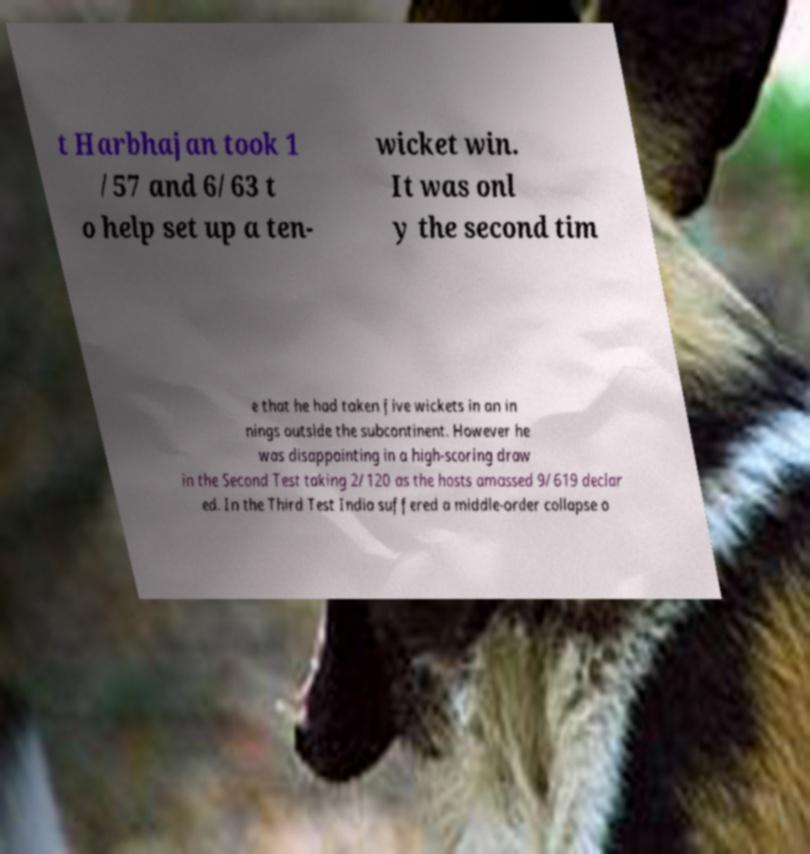There's text embedded in this image that I need extracted. Can you transcribe it verbatim? t Harbhajan took 1 /57 and 6/63 t o help set up a ten- wicket win. It was onl y the second tim e that he had taken five wickets in an in nings outside the subcontinent. However he was disappointing in a high-scoring draw in the Second Test taking 2/120 as the hosts amassed 9/619 declar ed. In the Third Test India suffered a middle-order collapse o 